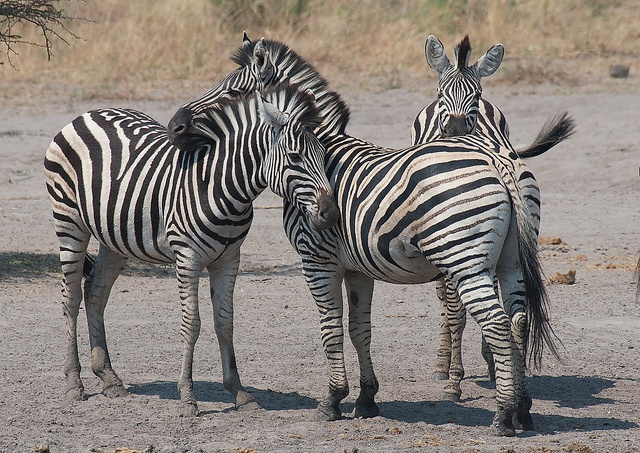Describe the objects in this image and their specific colors. I can see zebra in tan, black, gray, darkgray, and lightgray tones, zebra in tan, black, gray, darkgray, and lightgray tones, and zebra in tan, gray, black, darkgray, and lightgray tones in this image. 